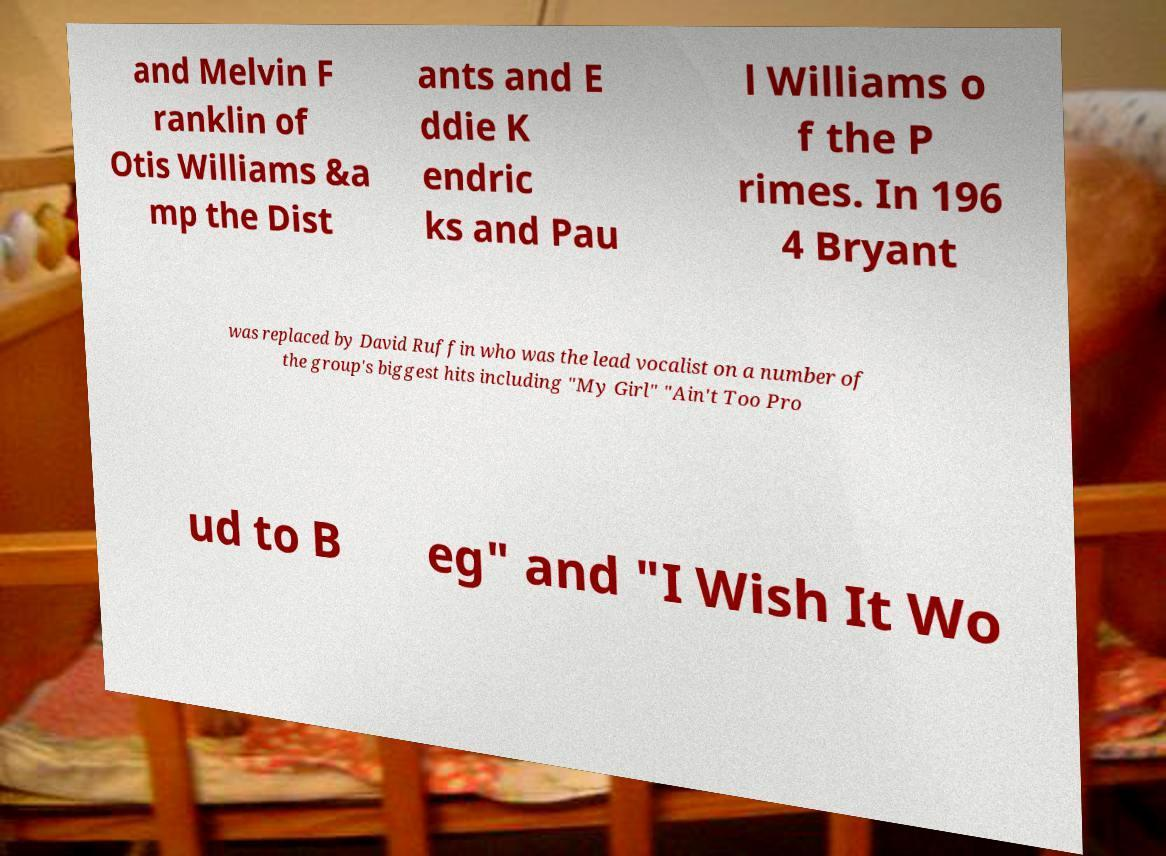Can you accurately transcribe the text from the provided image for me? and Melvin F ranklin of Otis Williams &a mp the Dist ants and E ddie K endric ks and Pau l Williams o f the P rimes. In 196 4 Bryant was replaced by David Ruffin who was the lead vocalist on a number of the group's biggest hits including "My Girl" "Ain't Too Pro ud to B eg" and "I Wish It Wo 